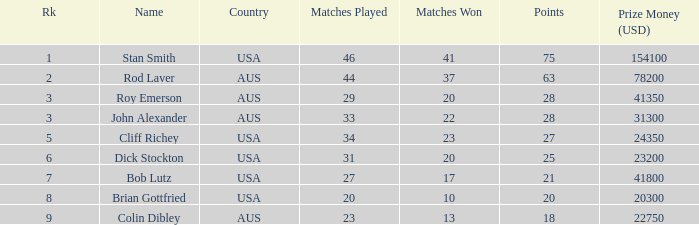What was the total count of matches won by colin dibley? 13.0. 